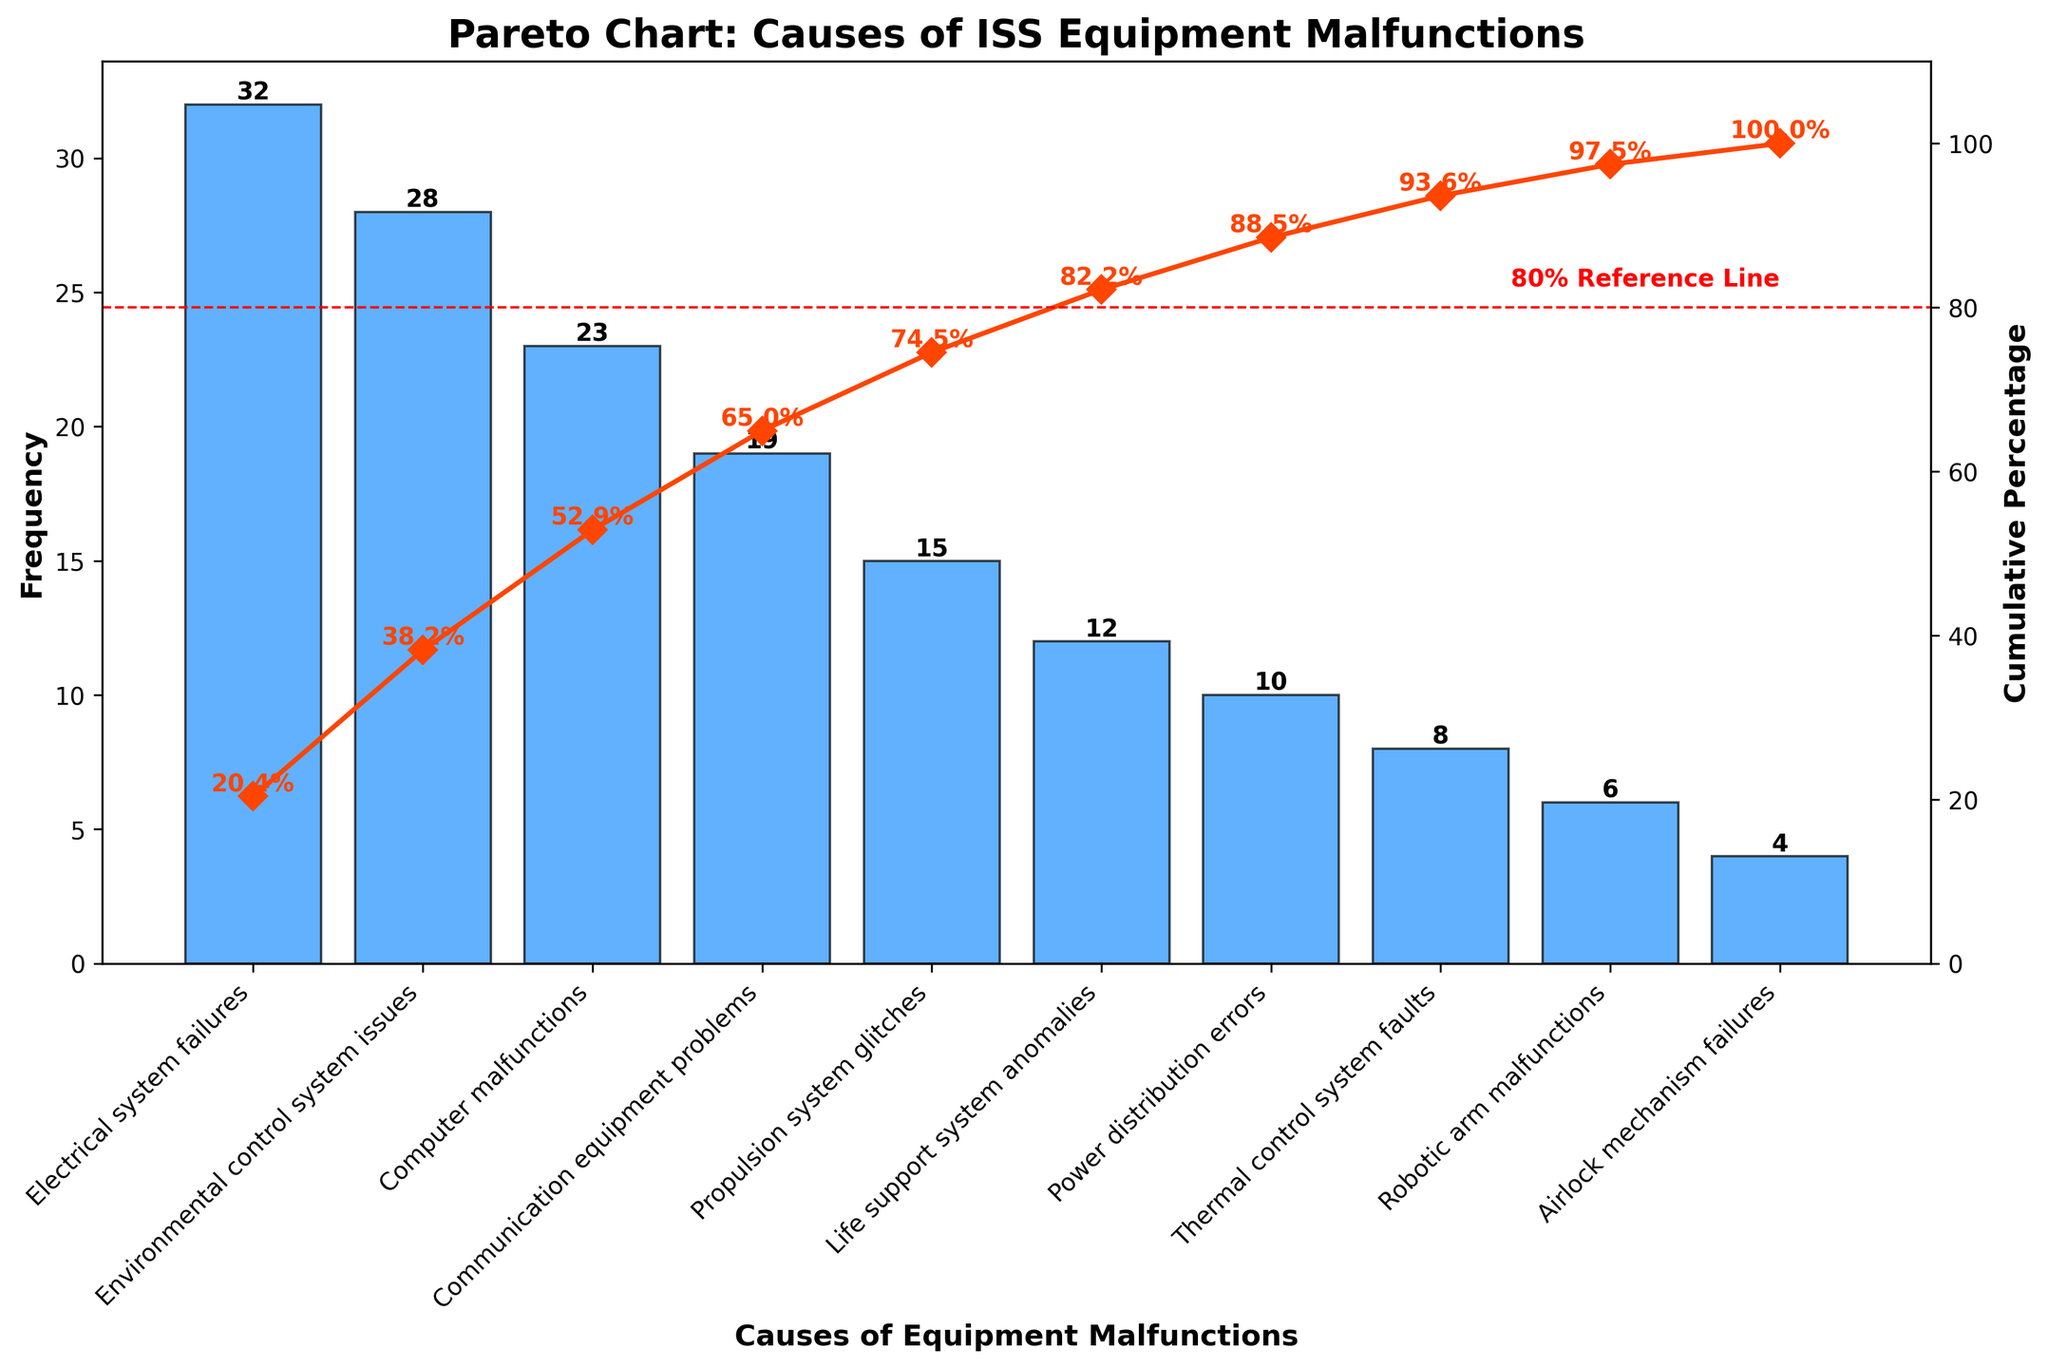What is the most common cause of equipment malfunctions on the ISS? By looking at the bar with the highest frequency, it is clear that the most common cause is "Electrical system failures" with a frequency of 32.
Answer: Electrical system failures What is the title of the chart? The title of the chart is displayed at the top of the figure, which reads "Pareto Chart: Causes of ISS Equipment Malfunctions".
Answer: Pareto Chart: Causes of ISS Equipment Malfunctions How many causes result in fewer than 10 malfunctions? Look at the bars with frequencies below 10 and count them: Robotic arm malfunctions (6) and Airlock mechanism failures (4). This gives us two bars.
Answer: 2 What is the cumulative percentage after the first three causes? Identify the cumulative percentages for the first three bars: Electrical system failures, Environmental control system issues, and Computer malfunctions. Their cumulative percentages are 20.9%, 39.8%, and 54.9%, respectively. Add them together to find the percentage after the first three bars.
Answer: 75.6% Which cause is responsible for 23 malfunctions? Look at the bar with the frequency of 23; the label indicates that "Computer malfunctions" is responsible for 23 malfunctions.
Answer: Computer malfunctions Which malfunction cause is directly above the 80% reference line on the cumulative percentage curve? Trace the red dashed 80% reference line sideways to intersect the cumulative percentage curve, and see that "Life support system anomalies" is directly above it.
Answer: Life support system anomalies By how much does the frequency of Electrical system failures exceed the frequency of Propulsion system glitches? Identify the frequencies: Electrical system failures (32) and Propulsion system glitches (15). Subtract the smaller from the larger value: 32 - 15 = 17.
Answer: 17 What is the cumulative percentage for "Communication equipment problems"? Trace the curve to the top of the bar labeled "Communication equipment problems," whose cumulative percentage is around 81.5%.
Answer: 81.5% Which cause has the lowest frequency of malfunctions? Identify the bar with the lowest height, which is "Airlock mechanism failures" with a frequency of 4.
Answer: Airlock mechanism failures 